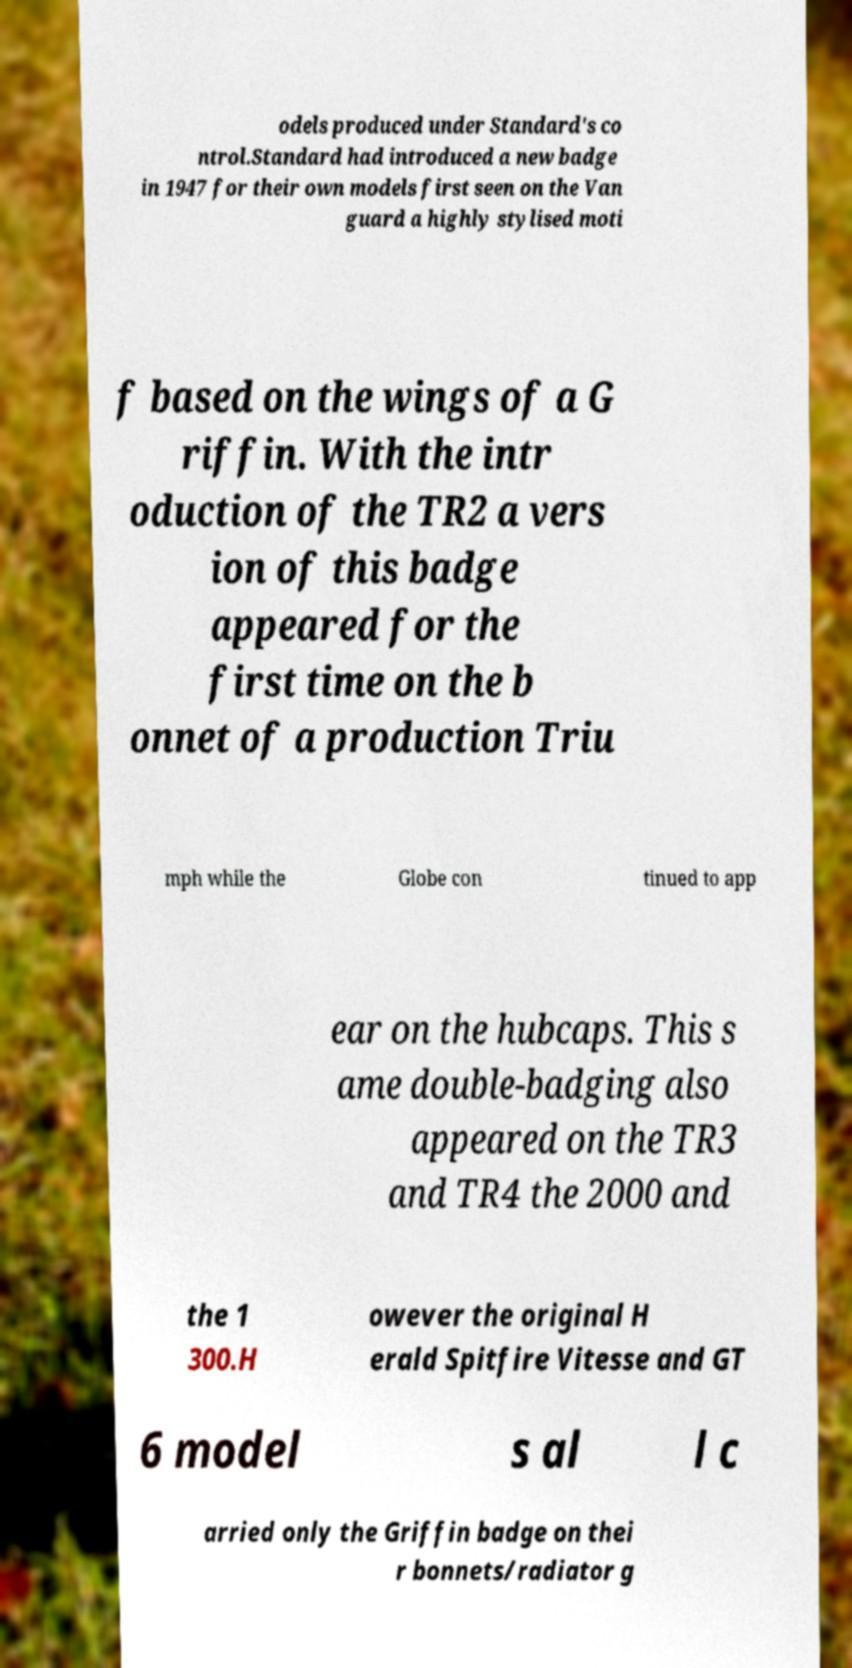Could you assist in decoding the text presented in this image and type it out clearly? odels produced under Standard's co ntrol.Standard had introduced a new badge in 1947 for their own models first seen on the Van guard a highly stylised moti f based on the wings of a G riffin. With the intr oduction of the TR2 a vers ion of this badge appeared for the first time on the b onnet of a production Triu mph while the Globe con tinued to app ear on the hubcaps. This s ame double-badging also appeared on the TR3 and TR4 the 2000 and the 1 300.H owever the original H erald Spitfire Vitesse and GT 6 model s al l c arried only the Griffin badge on thei r bonnets/radiator g 